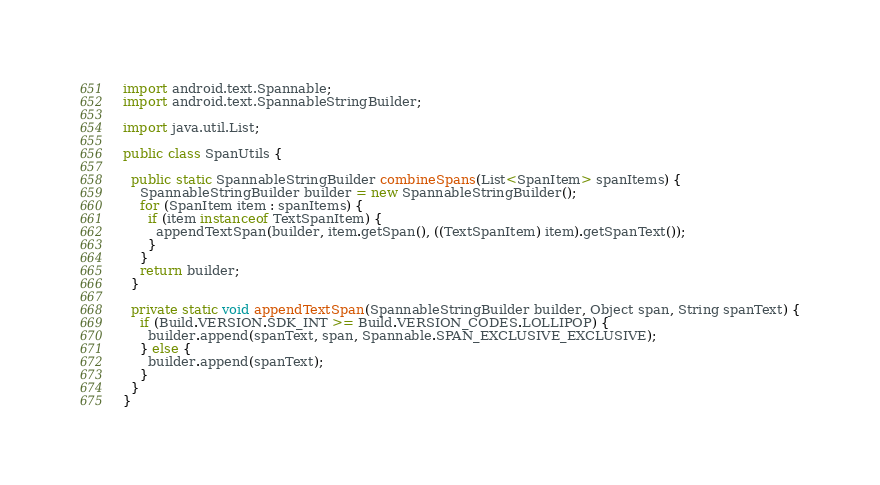<code> <loc_0><loc_0><loc_500><loc_500><_Java_>import android.text.Spannable;
import android.text.SpannableStringBuilder;

import java.util.List;

public class SpanUtils {

  public static SpannableStringBuilder combineSpans(List<SpanItem> spanItems) {
    SpannableStringBuilder builder = new SpannableStringBuilder();
    for (SpanItem item : spanItems) {
      if (item instanceof TextSpanItem) {
        appendTextSpan(builder, item.getSpan(), ((TextSpanItem) item).getSpanText());
      }
    }
    return builder;
  }

  private static void appendTextSpan(SpannableStringBuilder builder, Object span, String spanText) {
    if (Build.VERSION.SDK_INT >= Build.VERSION_CODES.LOLLIPOP) {
      builder.append(spanText, span, Spannable.SPAN_EXCLUSIVE_EXCLUSIVE);
    } else {
      builder.append(spanText);
    }
  }
}
</code> 